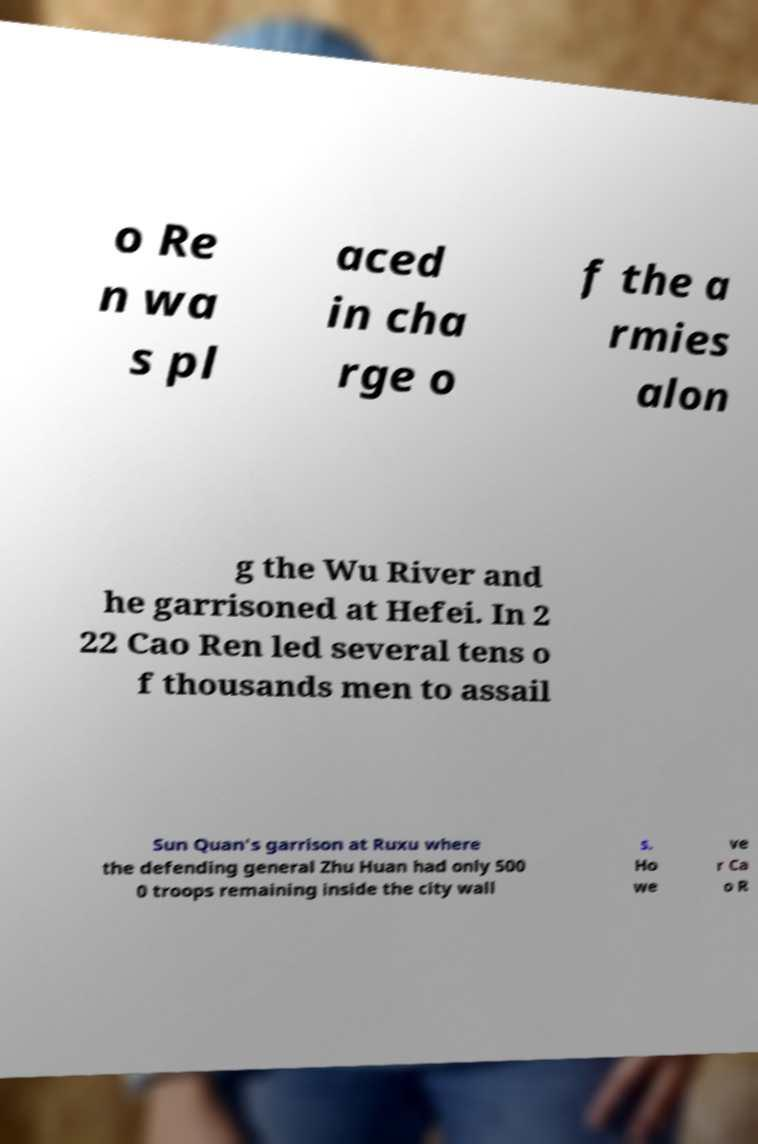What messages or text are displayed in this image? I need them in a readable, typed format. o Re n wa s pl aced in cha rge o f the a rmies alon g the Wu River and he garrisoned at Hefei. In 2 22 Cao Ren led several tens o f thousands men to assail Sun Quan's garrison at Ruxu where the defending general Zhu Huan had only 500 0 troops remaining inside the city wall s. Ho we ve r Ca o R 